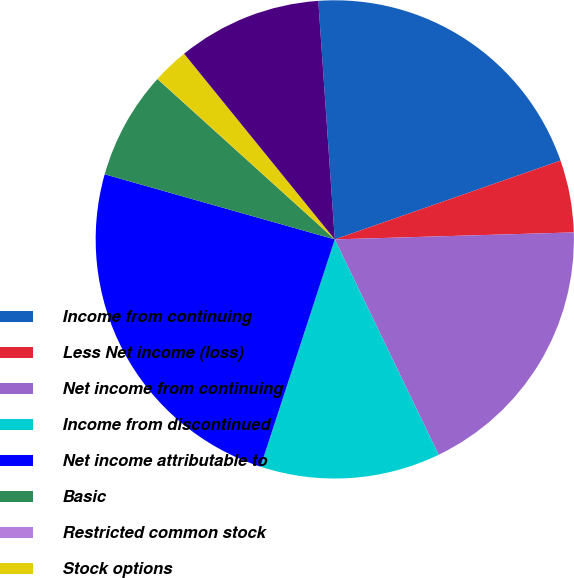<chart> <loc_0><loc_0><loc_500><loc_500><pie_chart><fcel>Income from continuing<fcel>Less Net income (loss)<fcel>Net income from continuing<fcel>Income from discontinued<fcel>Net income attributable to<fcel>Basic<fcel>Restricted common stock<fcel>Stock options<fcel>Diluted<nl><fcel>20.75%<fcel>4.88%<fcel>18.31%<fcel>12.18%<fcel>24.36%<fcel>7.31%<fcel>0.01%<fcel>2.44%<fcel>9.75%<nl></chart> 